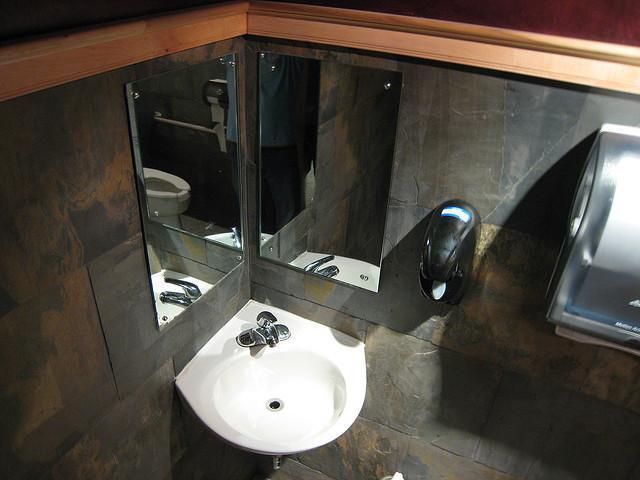How many mirrors are there?
Give a very brief answer. 2. How many of the umbrellas are folded?
Give a very brief answer. 0. 